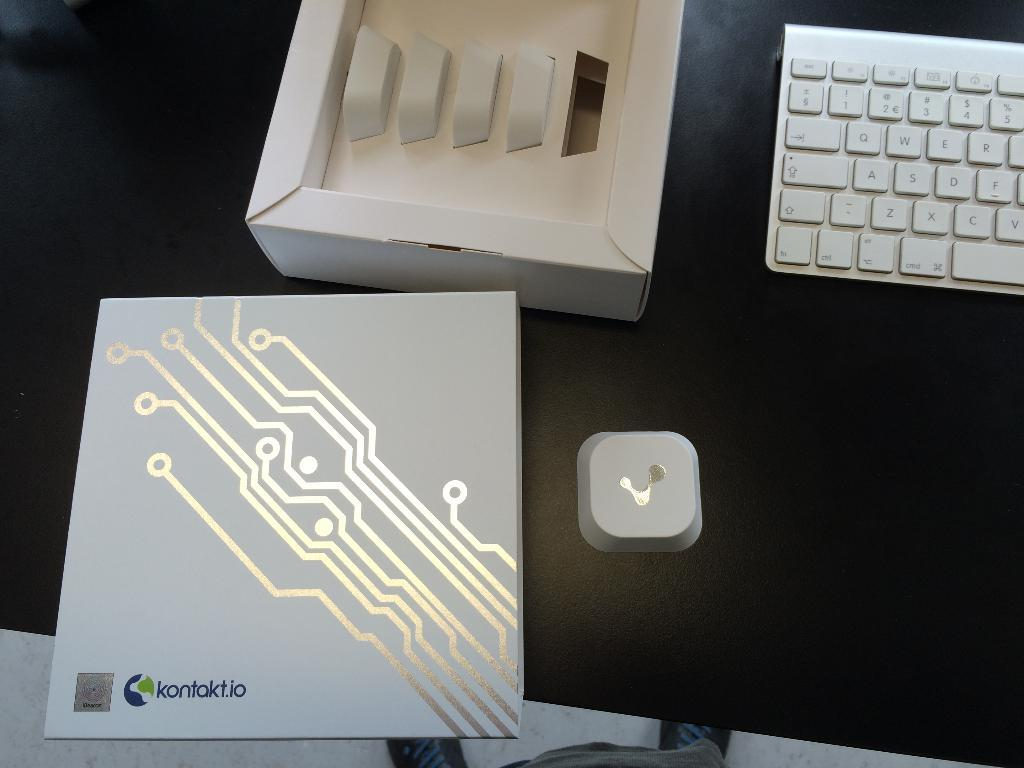Provide a one-sentence caption for the provided image. The keyboard was made by the name Kontak.io. 